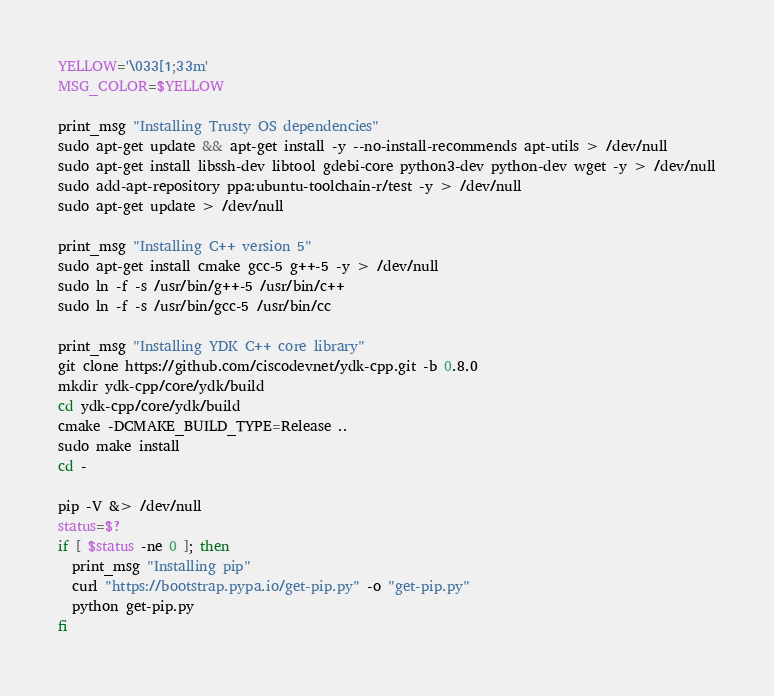Convert code to text. <code><loc_0><loc_0><loc_500><loc_500><_Bash_>YELLOW='\033[1;33m'
MSG_COLOR=$YELLOW

print_msg "Installing Trusty OS dependencies"
sudo apt-get update && apt-get install -y --no-install-recommends apt-utils > /dev/null
sudo apt-get install libssh-dev libtool gdebi-core python3-dev python-dev wget -y > /dev/null
sudo add-apt-repository ppa:ubuntu-toolchain-r/test -y > /dev/null
sudo apt-get update > /dev/null

print_msg "Installing C++ version 5"
sudo apt-get install cmake gcc-5 g++-5 -y > /dev/null
sudo ln -f -s /usr/bin/g++-5 /usr/bin/c++
sudo ln -f -s /usr/bin/gcc-5 /usr/bin/cc

print_msg "Installing YDK C++ core library"
git clone https://github.com/ciscodevnet/ydk-cpp.git -b 0.8.0
mkdir ydk-cpp/core/ydk/build
cd ydk-cpp/core/ydk/build
cmake -DCMAKE_BUILD_TYPE=Release ..
sudo make install
cd -

pip -V &> /dev/null
status=$?
if [ $status -ne 0 ]; then
  print_msg "Installing pip"
  curl "https://bootstrap.pypa.io/get-pip.py" -o "get-pip.py"
  python get-pip.py
fi
</code> 